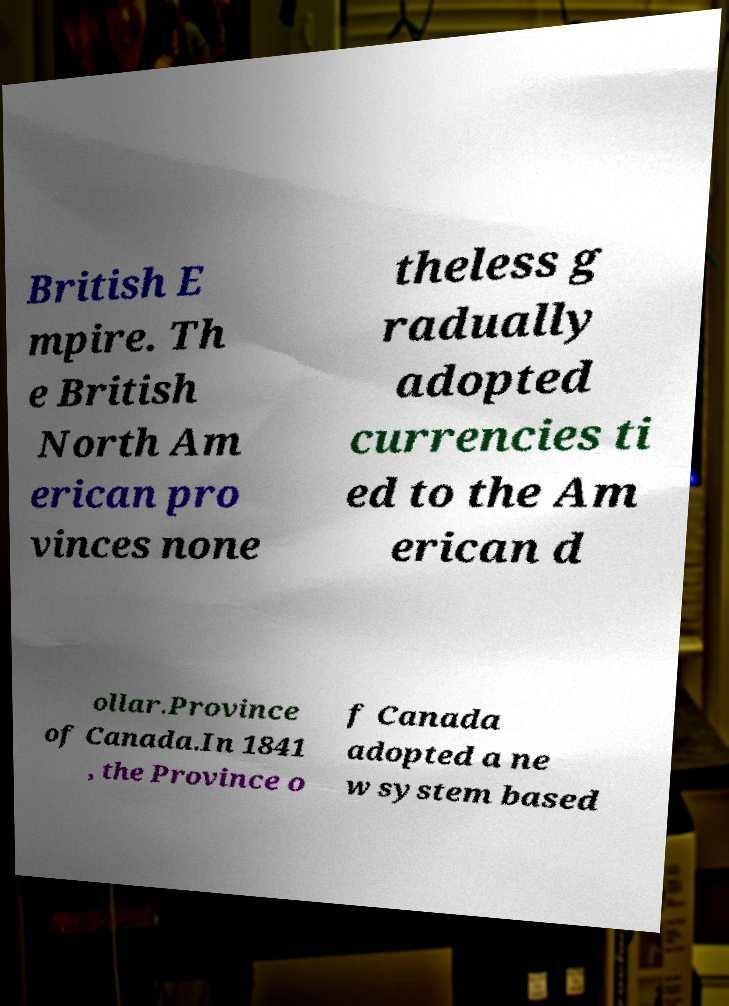Could you assist in decoding the text presented in this image and type it out clearly? British E mpire. Th e British North Am erican pro vinces none theless g radually adopted currencies ti ed to the Am erican d ollar.Province of Canada.In 1841 , the Province o f Canada adopted a ne w system based 